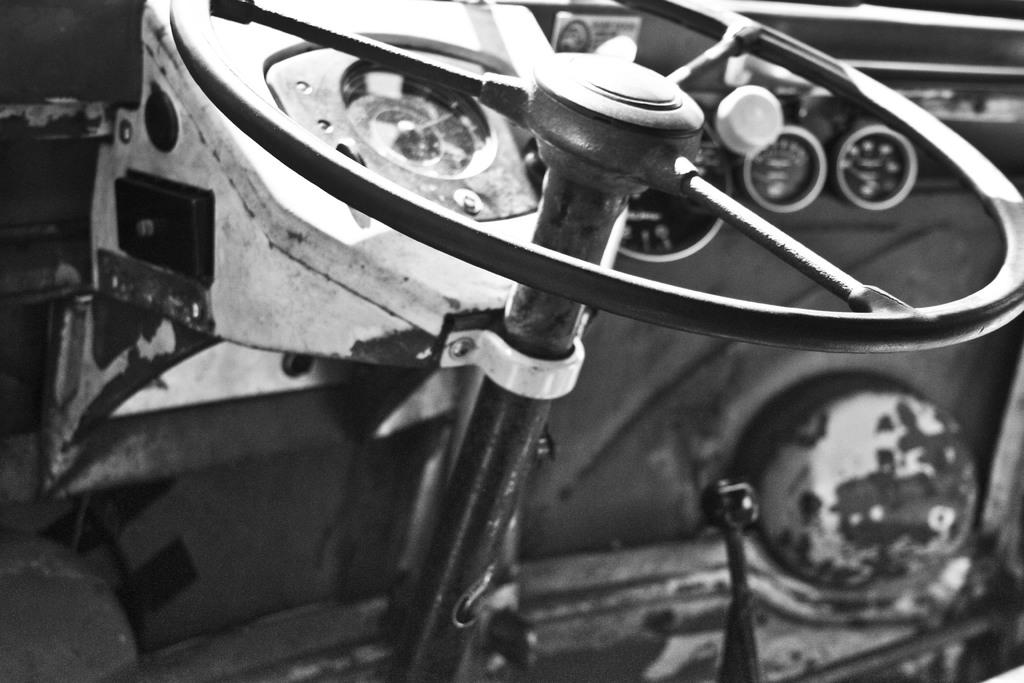What object is the main focus of the image? The main focus of the image is a steering wheel. Where is the steering wheel located? The steering wheel is inside a vehicle. What type of pest can be seen crawling on the steering wheel in the image? There are no pests visible in the image, as it only features a steering wheel inside a vehicle. 